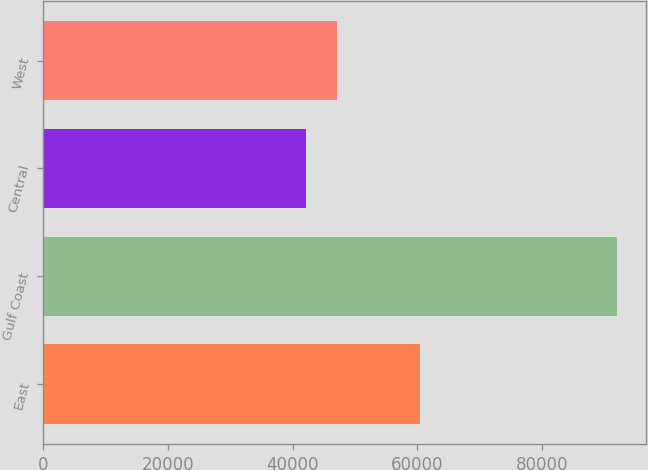<chart> <loc_0><loc_0><loc_500><loc_500><bar_chart><fcel>East<fcel>Gulf Coast<fcel>Central<fcel>West<nl><fcel>60494<fcel>92095<fcel>42182<fcel>47173.3<nl></chart> 